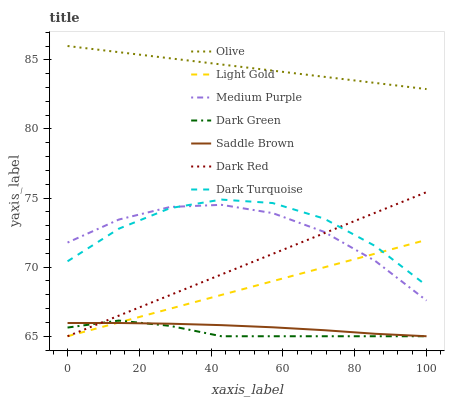Does Medium Purple have the minimum area under the curve?
Answer yes or no. No. Does Medium Purple have the maximum area under the curve?
Answer yes or no. No. Is Medium Purple the smoothest?
Answer yes or no. No. Is Medium Purple the roughest?
Answer yes or no. No. Does Medium Purple have the lowest value?
Answer yes or no. No. Does Medium Purple have the highest value?
Answer yes or no. No. Is Medium Purple less than Olive?
Answer yes or no. Yes. Is Olive greater than Medium Purple?
Answer yes or no. Yes. Does Medium Purple intersect Olive?
Answer yes or no. No. 